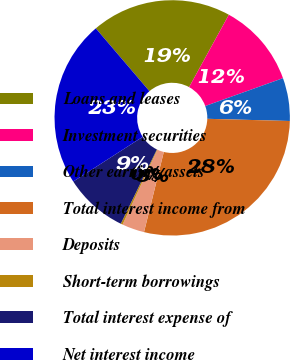Convert chart. <chart><loc_0><loc_0><loc_500><loc_500><pie_chart><fcel>Loans and leases<fcel>Investment securities<fcel>Other earning assets<fcel>Total interest income from<fcel>Deposits<fcel>Short-term borrowings<fcel>Total interest expense of<fcel>Net interest income<nl><fcel>19.24%<fcel>11.53%<fcel>5.9%<fcel>28.43%<fcel>3.08%<fcel>0.26%<fcel>8.71%<fcel>22.85%<nl></chart> 